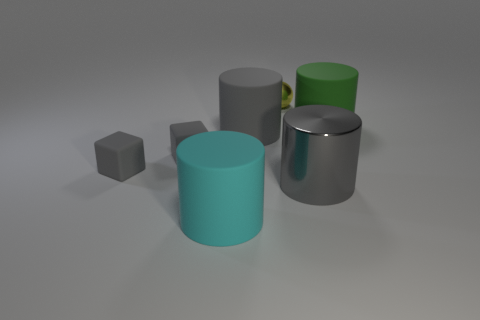What is the color of the small object that is behind the green rubber cylinder?
Keep it short and to the point. Yellow. What is the shape of the big gray matte object?
Offer a terse response. Cylinder. Is there a small matte thing right of the large gray thing that is on the left side of the tiny thing that is to the right of the cyan thing?
Your answer should be very brief. No. What color is the big rubber thing that is on the right side of the object behind the large matte object to the right of the gray metallic cylinder?
Provide a succinct answer. Green. There is a green thing that is the same shape as the cyan thing; what is it made of?
Offer a terse response. Rubber. How big is the rubber cylinder in front of the metal thing right of the yellow metallic ball?
Keep it short and to the point. Large. There is a object that is in front of the gray metallic thing; what is its material?
Offer a very short reply. Rubber. What number of cyan rubber things are the same shape as the green object?
Your response must be concise. 1. Is the shape of the big green thing the same as the metal thing right of the tiny shiny object?
Make the answer very short. Yes. Is there a small object made of the same material as the big green object?
Ensure brevity in your answer.  Yes. 